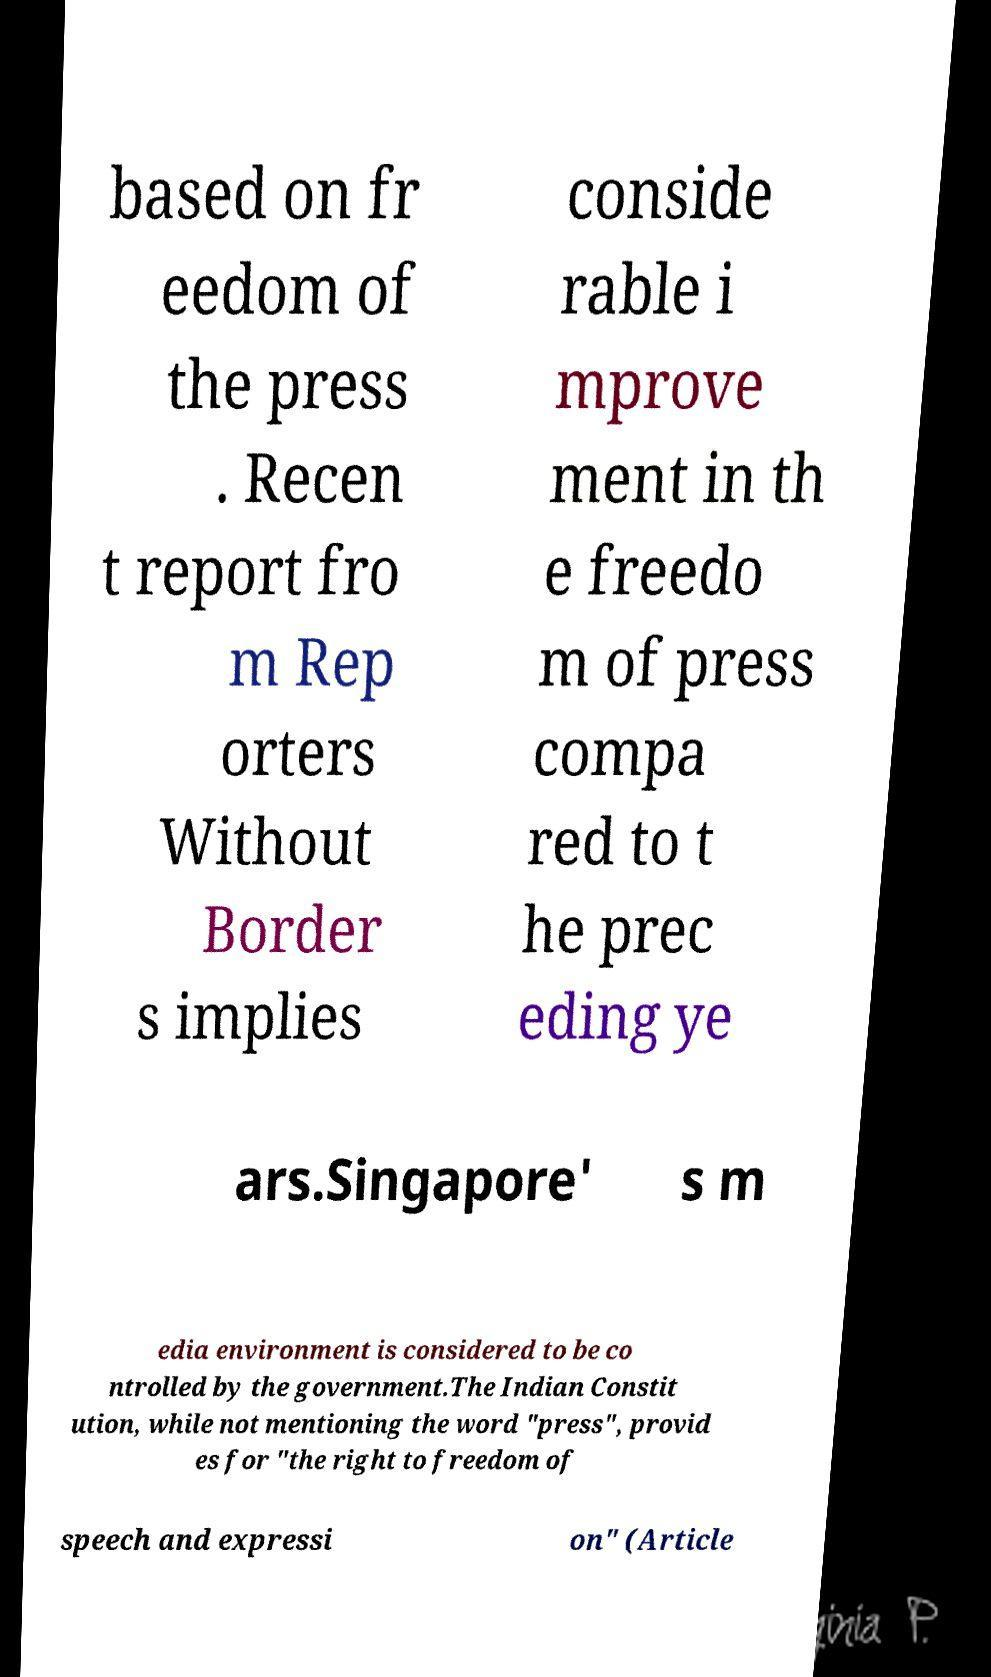For documentation purposes, I need the text within this image transcribed. Could you provide that? based on fr eedom of the press . Recen t report fro m Rep orters Without Border s implies conside rable i mprove ment in th e freedo m of press compa red to t he prec eding ye ars.Singapore' s m edia environment is considered to be co ntrolled by the government.The Indian Constit ution, while not mentioning the word "press", provid es for "the right to freedom of speech and expressi on" (Article 